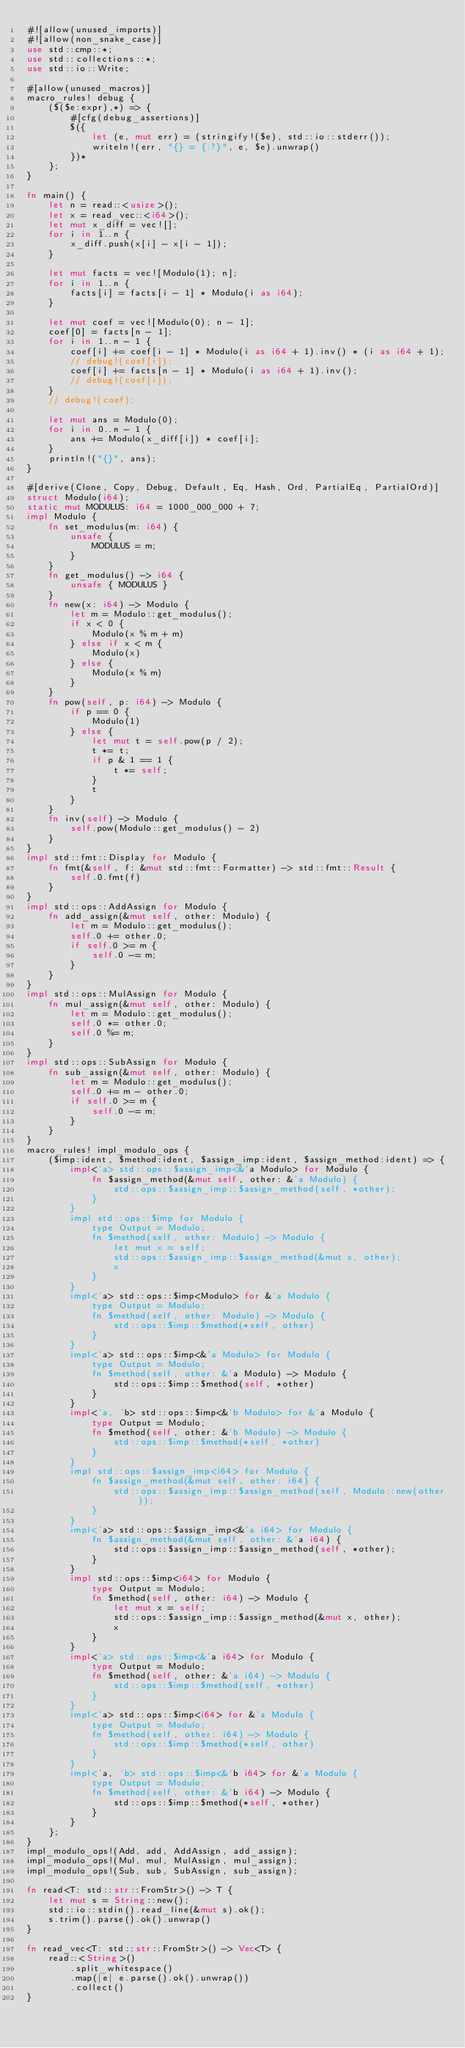<code> <loc_0><loc_0><loc_500><loc_500><_Rust_>#![allow(unused_imports)]
#![allow(non_snake_case)]
use std::cmp::*;
use std::collections::*;
use std::io::Write;

#[allow(unused_macros)]
macro_rules! debug {
    ($($e:expr),*) => {
        #[cfg(debug_assertions)]
        $({
            let (e, mut err) = (stringify!($e), std::io::stderr());
            writeln!(err, "{} = {:?}", e, $e).unwrap()
        })*
    };
}

fn main() {
    let n = read::<usize>();
    let x = read_vec::<i64>();
    let mut x_diff = vec![];
    for i in 1..n {
        x_diff.push(x[i] - x[i - 1]);
    }

    let mut facts = vec![Modulo(1); n];
    for i in 1..n {
        facts[i] = facts[i - 1] * Modulo(i as i64);
    }

    let mut coef = vec![Modulo(0); n - 1];
    coef[0] = facts[n - 1];
    for i in 1..n - 1 {
        coef[i] += coef[i - 1] * Modulo(i as i64 + 1).inv() * (i as i64 + 1);
        // debug!(coef[i]);
        coef[i] += facts[n - 1] * Modulo(i as i64 + 1).inv();
        // debug!(coef[i]);
    }
    // debug!(coef);

    let mut ans = Modulo(0);
    for i in 0..n - 1 {
        ans += Modulo(x_diff[i]) * coef[i];
    }
    println!("{}", ans);
}

#[derive(Clone, Copy, Debug, Default, Eq, Hash, Ord, PartialEq, PartialOrd)]
struct Modulo(i64);
static mut MODULUS: i64 = 1000_000_000 + 7;
impl Modulo {
    fn set_modulus(m: i64) {
        unsafe {
            MODULUS = m;
        }
    }
    fn get_modulus() -> i64 {
        unsafe { MODULUS }
    }
    fn new(x: i64) -> Modulo {
        let m = Modulo::get_modulus();
        if x < 0 {
            Modulo(x % m + m)
        } else if x < m {
            Modulo(x)
        } else {
            Modulo(x % m)
        }
    }
    fn pow(self, p: i64) -> Modulo {
        if p == 0 {
            Modulo(1)
        } else {
            let mut t = self.pow(p / 2);
            t *= t;
            if p & 1 == 1 {
                t *= self;
            }
            t
        }
    }
    fn inv(self) -> Modulo {
        self.pow(Modulo::get_modulus() - 2)
    }
}
impl std::fmt::Display for Modulo {
    fn fmt(&self, f: &mut std::fmt::Formatter) -> std::fmt::Result {
        self.0.fmt(f)
    }
}
impl std::ops::AddAssign for Modulo {
    fn add_assign(&mut self, other: Modulo) {
        let m = Modulo::get_modulus();
        self.0 += other.0;
        if self.0 >= m {
            self.0 -= m;
        }
    }
}
impl std::ops::MulAssign for Modulo {
    fn mul_assign(&mut self, other: Modulo) {
        let m = Modulo::get_modulus();
        self.0 *= other.0;
        self.0 %= m;
    }
}
impl std::ops::SubAssign for Modulo {
    fn sub_assign(&mut self, other: Modulo) {
        let m = Modulo::get_modulus();
        self.0 += m - other.0;
        if self.0 >= m {
            self.0 -= m;
        }
    }
}
macro_rules! impl_modulo_ops {
    ($imp:ident, $method:ident, $assign_imp:ident, $assign_method:ident) => {
        impl<'a> std::ops::$assign_imp<&'a Modulo> for Modulo {
            fn $assign_method(&mut self, other: &'a Modulo) {
                std::ops::$assign_imp::$assign_method(self, *other);
            }
        }
        impl std::ops::$imp for Modulo {
            type Output = Modulo;
            fn $method(self, other: Modulo) -> Modulo {
                let mut x = self;
                std::ops::$assign_imp::$assign_method(&mut x, other);
                x
            }
        }
        impl<'a> std::ops::$imp<Modulo> for &'a Modulo {
            type Output = Modulo;
            fn $method(self, other: Modulo) -> Modulo {
                std::ops::$imp::$method(*self, other)
            }
        }
        impl<'a> std::ops::$imp<&'a Modulo> for Modulo {
            type Output = Modulo;
            fn $method(self, other: &'a Modulo) -> Modulo {
                std::ops::$imp::$method(self, *other)
            }
        }
        impl<'a, 'b> std::ops::$imp<&'b Modulo> for &'a Modulo {
            type Output = Modulo;
            fn $method(self, other: &'b Modulo) -> Modulo {
                std::ops::$imp::$method(*self, *other)
            }
        }
        impl std::ops::$assign_imp<i64> for Modulo {
            fn $assign_method(&mut self, other: i64) {
                std::ops::$assign_imp::$assign_method(self, Modulo::new(other));
            }
        }
        impl<'a> std::ops::$assign_imp<&'a i64> for Modulo {
            fn $assign_method(&mut self, other: &'a i64) {
                std::ops::$assign_imp::$assign_method(self, *other);
            }
        }
        impl std::ops::$imp<i64> for Modulo {
            type Output = Modulo;
            fn $method(self, other: i64) -> Modulo {
                let mut x = self;
                std::ops::$assign_imp::$assign_method(&mut x, other);
                x
            }
        }
        impl<'a> std::ops::$imp<&'a i64> for Modulo {
            type Output = Modulo;
            fn $method(self, other: &'a i64) -> Modulo {
                std::ops::$imp::$method(self, *other)
            }
        }
        impl<'a> std::ops::$imp<i64> for &'a Modulo {
            type Output = Modulo;
            fn $method(self, other: i64) -> Modulo {
                std::ops::$imp::$method(*self, other)
            }
        }
        impl<'a, 'b> std::ops::$imp<&'b i64> for &'a Modulo {
            type Output = Modulo;
            fn $method(self, other: &'b i64) -> Modulo {
                std::ops::$imp::$method(*self, *other)
            }
        }
    };
}
impl_modulo_ops!(Add, add, AddAssign, add_assign);
impl_modulo_ops!(Mul, mul, MulAssign, mul_assign);
impl_modulo_ops!(Sub, sub, SubAssign, sub_assign);

fn read<T: std::str::FromStr>() -> T {
    let mut s = String::new();
    std::io::stdin().read_line(&mut s).ok();
    s.trim().parse().ok().unwrap()
}

fn read_vec<T: std::str::FromStr>() -> Vec<T> {
    read::<String>()
        .split_whitespace()
        .map(|e| e.parse().ok().unwrap())
        .collect()
}
</code> 